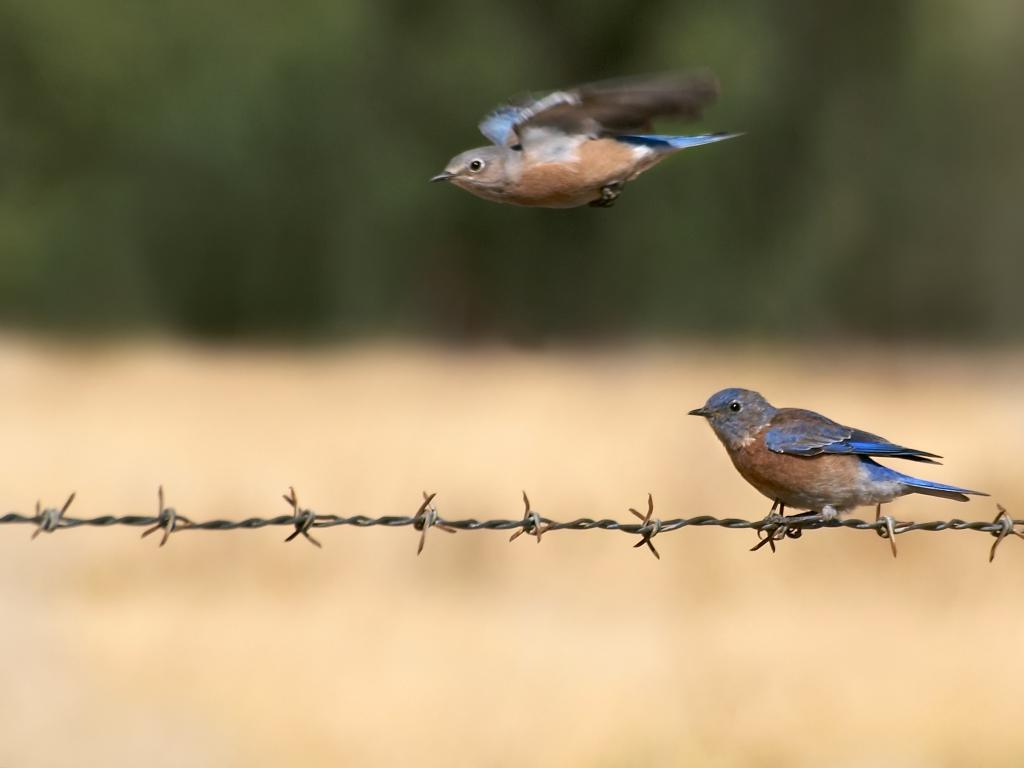How many birds are present in the image? There are two birds in the image. What colors can be seen on the birds? The birds have blue and brown coloring. What is the color of the background in the image? The background in the image is green. What type of cat can be seen playing with a wren in the image? There is no cat or wren present in the image; it features two birds with blue and brown coloring against a green background. 